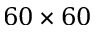<formula> <loc_0><loc_0><loc_500><loc_500>6 0 \times 6 0</formula> 